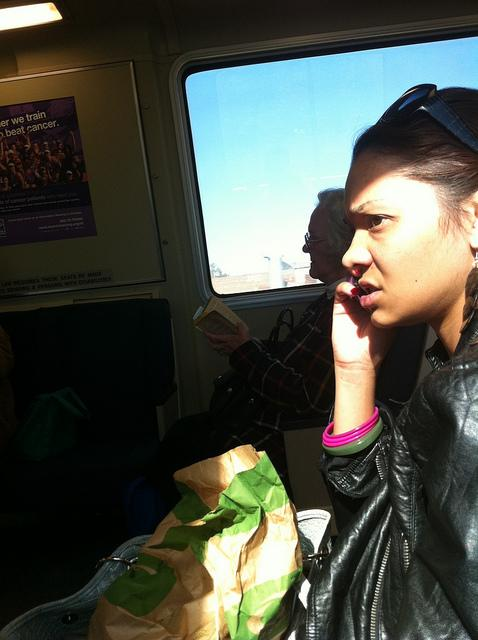What is the brown and green bag made from? paper 